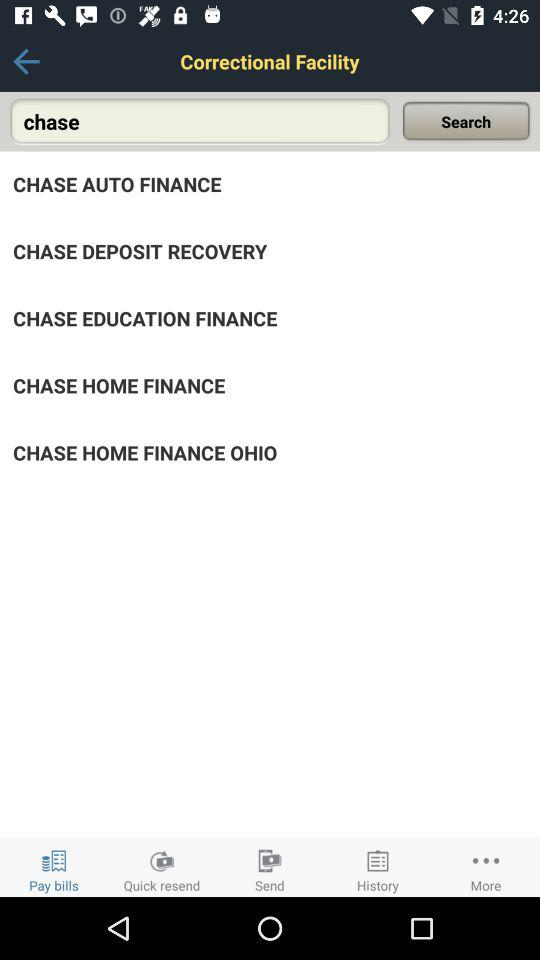How many notifications are there in "History"?
When the provided information is insufficient, respond with <no answer>. <no answer> 